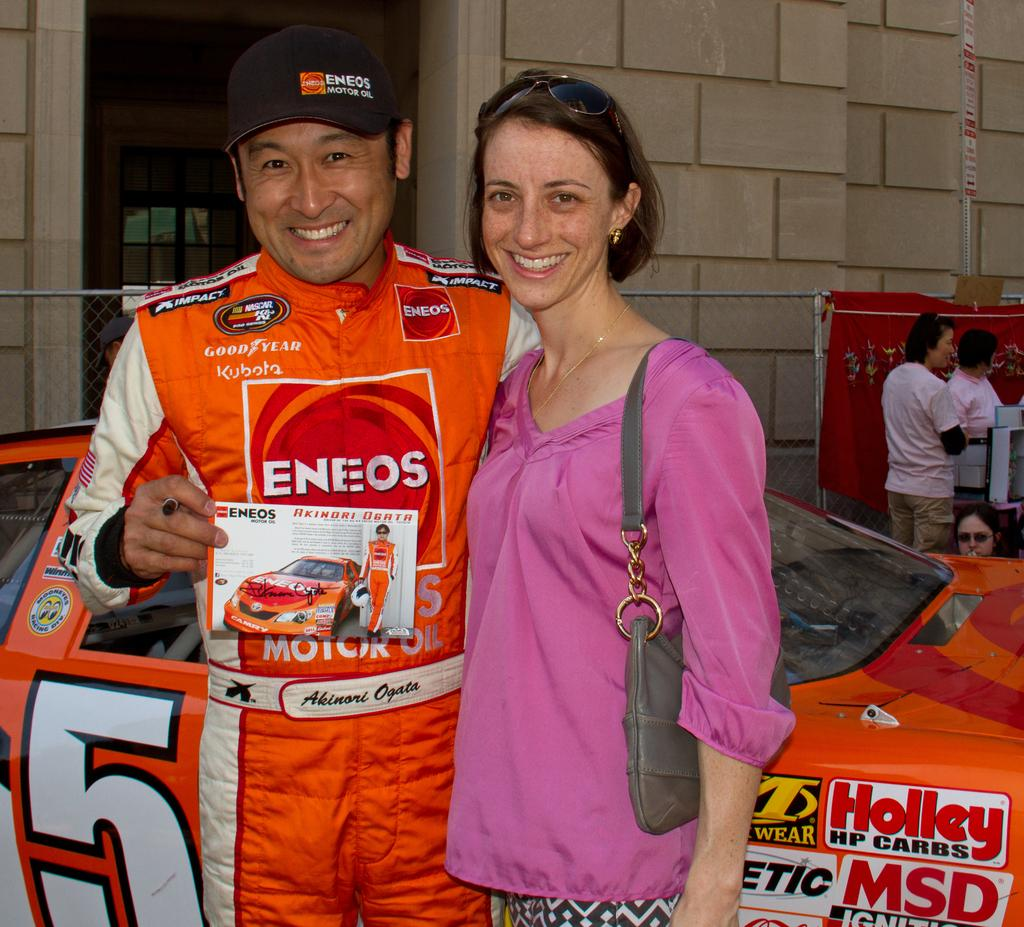<image>
Provide a brief description of the given image. a man with a lady in front of a car that has MSD on it 